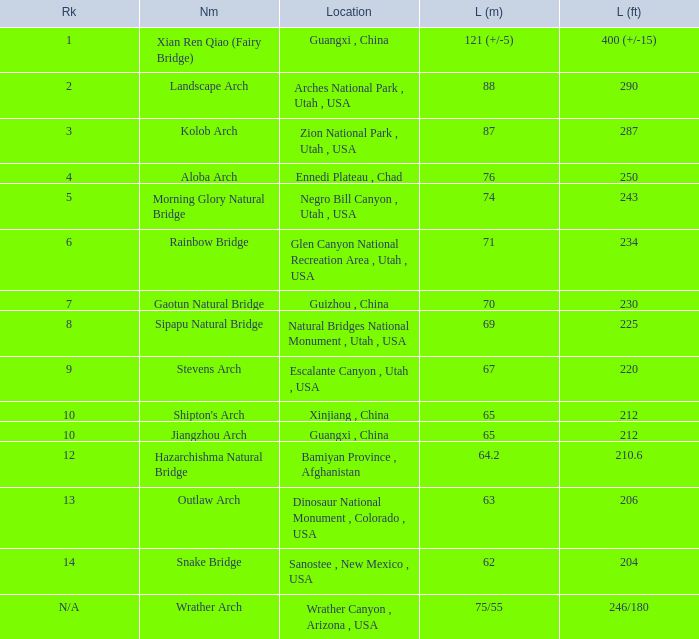In which location is the longest arch that measures 63 meters in length? Dinosaur National Monument , Colorado , USA. 